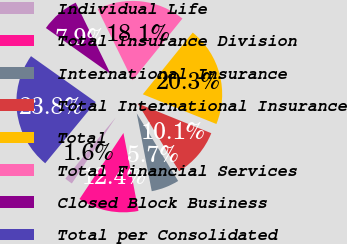Convert chart. <chart><loc_0><loc_0><loc_500><loc_500><pie_chart><fcel>Individual Life<fcel>Total Insurance Division<fcel>International Insurance<fcel>Total International Insurance<fcel>Total<fcel>Total Financial Services<fcel>Closed Block Business<fcel>Total per Consolidated<nl><fcel>1.64%<fcel>12.37%<fcel>5.71%<fcel>10.15%<fcel>20.29%<fcel>18.07%<fcel>7.93%<fcel>23.84%<nl></chart> 